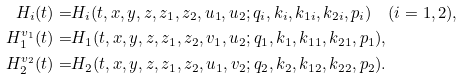<formula> <loc_0><loc_0><loc_500><loc_500>{ H } _ { i } ( t ) = & H _ { i } ( t , x , y , z , z _ { 1 } , z _ { 2 } , u _ { 1 } , u _ { 2 } ; q _ { i } , k _ { i } , k _ { 1 i } , k _ { 2 i } , p _ { i } ) \quad ( i = 1 , 2 ) , \\ { H } _ { 1 } ^ { v _ { 1 } } ( t ) = & H _ { 1 } ( t , x , y , z , z _ { 1 } , z _ { 2 } , v _ { 1 } , u _ { 2 } ; q _ { 1 } , k _ { 1 } , k _ { 1 1 } , k _ { 2 1 } , p _ { 1 } ) , \\ { H } _ { 2 } ^ { v _ { 2 } } ( t ) = & H _ { 2 } ( t , x , y , z , z _ { 1 } , z _ { 2 } , u _ { 1 } , v _ { 2 } ; q _ { 2 } , k _ { 2 } , k _ { 1 2 } , k _ { 2 2 } , p _ { 2 } ) .</formula> 